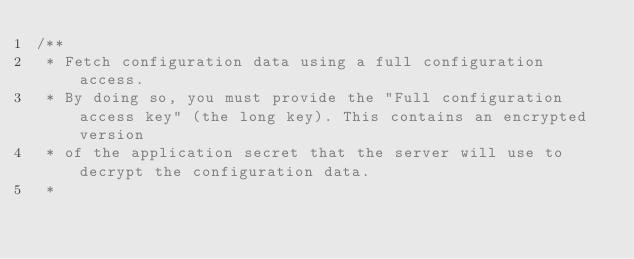Convert code to text. <code><loc_0><loc_0><loc_500><loc_500><_JavaScript_>/**
 * Fetch configuration data using a full configuration access.
 * By doing so, you must provide the "Full configuration access key" (the long key). This contains an encrypted version
 * of the application secret that the server will use to decrypt the configuration data.
 *</code> 